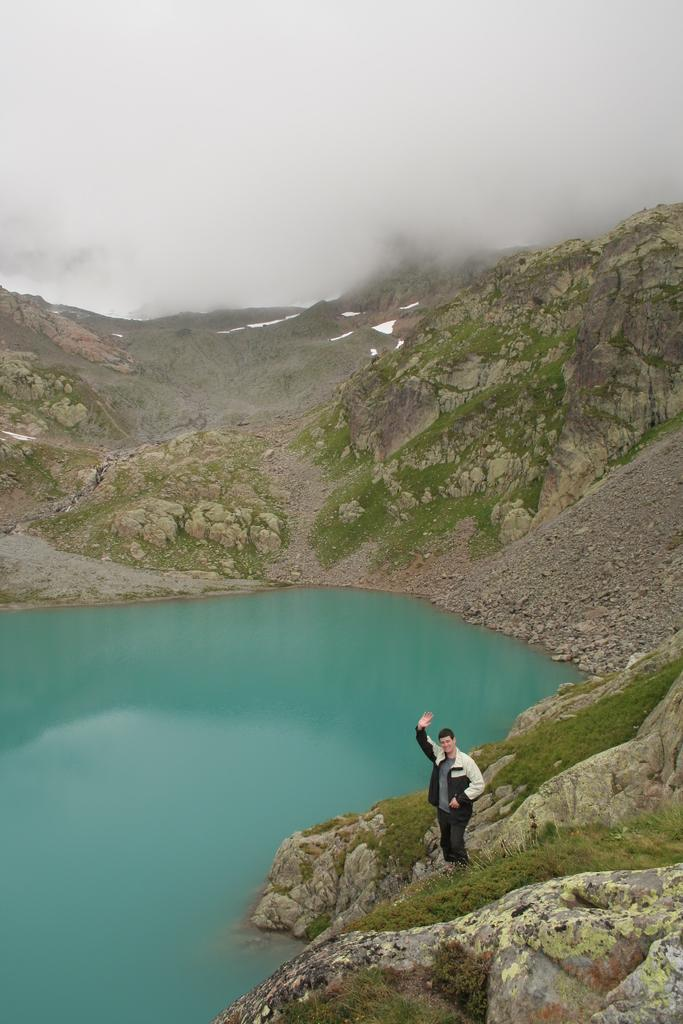What is the man in the image doing? The man is standing on a rock in the image. What can be seen in the distance behind the man? There are mountains, grass, water, and the sky visible in the background of the image. What type of pump can be seen in the image? There is no pump present in the image. How many clovers are visible on the grass in the image? There is no mention of clovers in the image, and they cannot be counted as they are not present. 